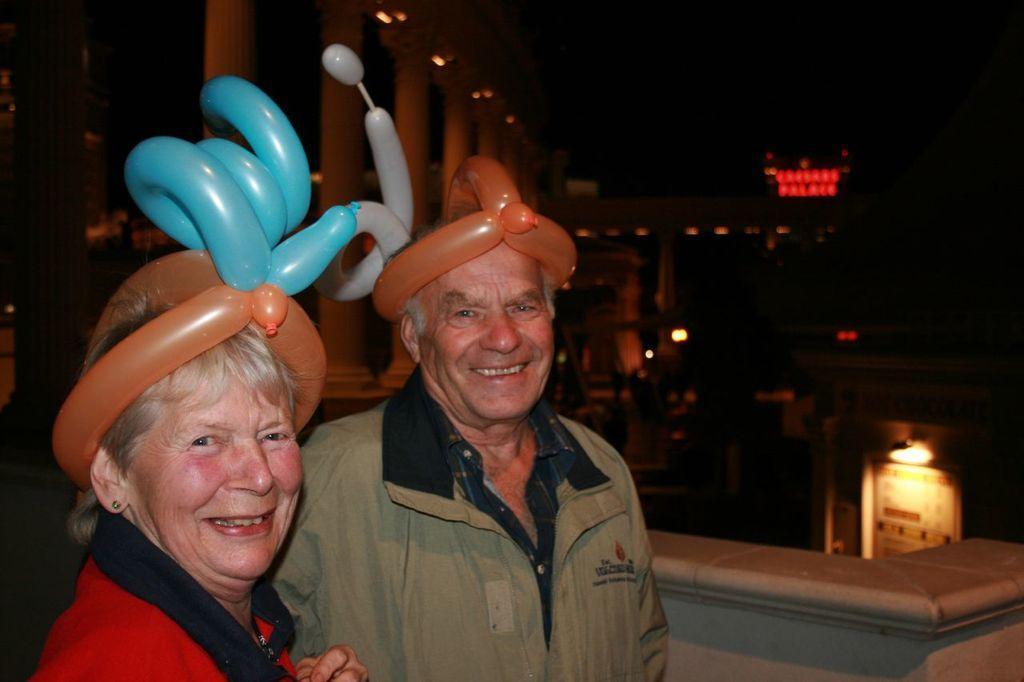In one or two sentences, can you explain what this image depicts? In this image I can see two persons smiling. There are buildings, lights, pillars and there is a dark background. 